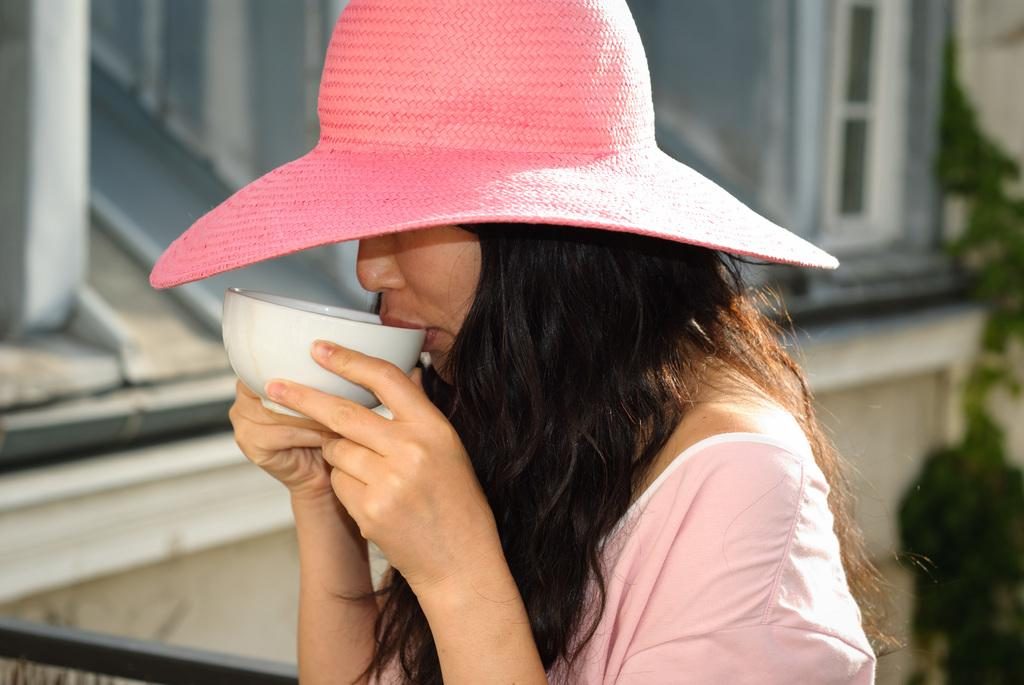Who is the main subject in the image? There is a woman in the image. What is the woman wearing on her head? The woman is wearing a pink hat. What is the woman doing with her hands in the image? The woman is holding a cup near her mouth. What historical event is taking place in the image? There is no historical event depicted in the image; it simply shows a woman wearing a pink hat and holding a cup near her mouth. What type of paste is being used by the woman in the image? There is no paste present in the image; the woman is holding a cup near her mouth. 